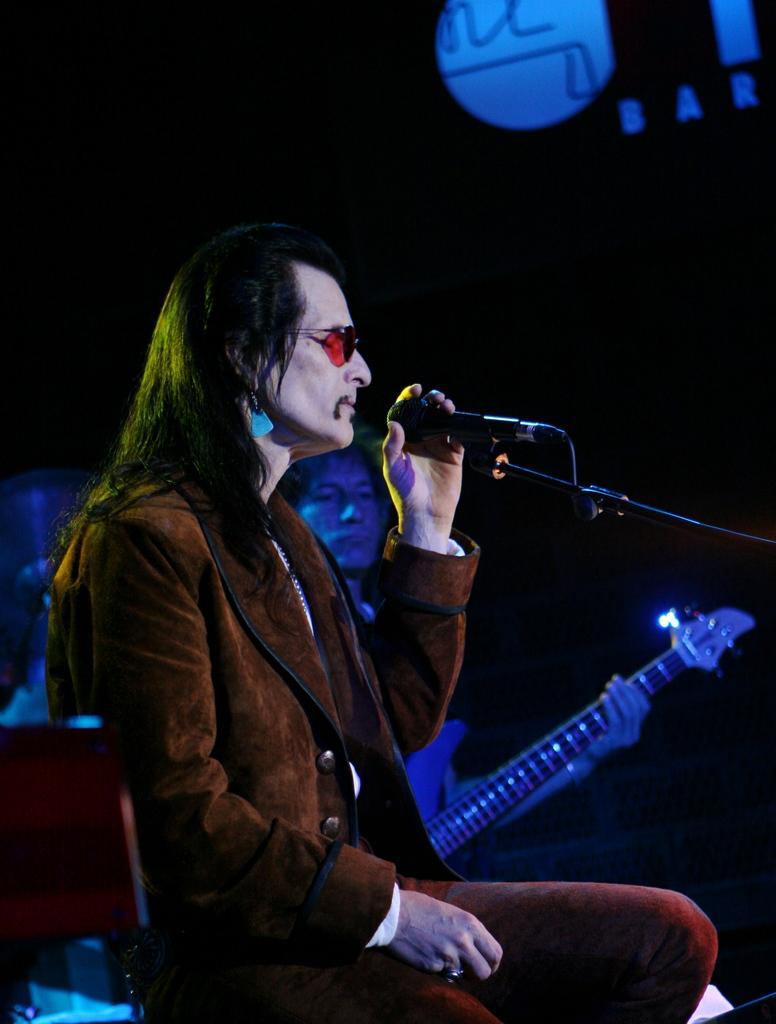What is the man in the image doing? The man is sitting and singing in front of a microphone. Who else is present in the image? There is another person in the image. What is the other person doing? The other person is playing a guitar. What type of print can be seen on the guitar in the image? There is no print visible on the guitar in the image; only the guitar itself and the person playing it are present. 